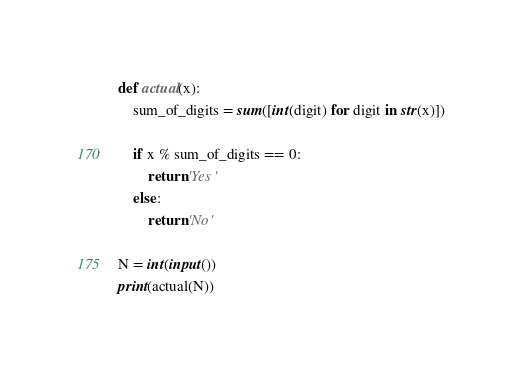<code> <loc_0><loc_0><loc_500><loc_500><_Python_>def actual(x):
    sum_of_digits = sum([int(digit) for digit in str(x)])

    if x % sum_of_digits == 0:
        return 'Yes'
    else:
        return 'No'

N = int(input())
print(actual(N))</code> 